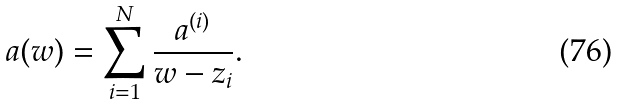Convert formula to latex. <formula><loc_0><loc_0><loc_500><loc_500>a ( w ) = \sum _ { i = 1 } ^ { N } \frac { a ^ { ( i ) } } { w - z _ { i } } .</formula> 